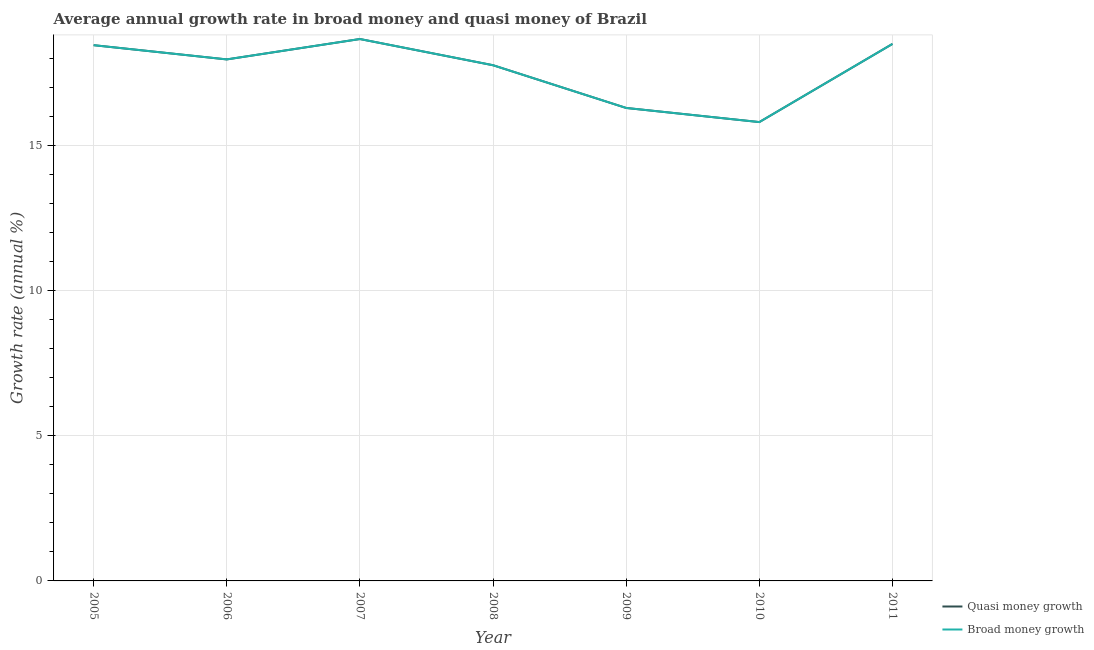Does the line corresponding to annual growth rate in broad money intersect with the line corresponding to annual growth rate in quasi money?
Give a very brief answer. Yes. What is the annual growth rate in broad money in 2005?
Your answer should be very brief. 18.47. Across all years, what is the maximum annual growth rate in broad money?
Offer a terse response. 18.68. Across all years, what is the minimum annual growth rate in broad money?
Ensure brevity in your answer.  15.82. What is the total annual growth rate in broad money in the graph?
Make the answer very short. 123.52. What is the difference between the annual growth rate in quasi money in 2009 and that in 2010?
Offer a very short reply. 0.49. What is the difference between the annual growth rate in quasi money in 2011 and the annual growth rate in broad money in 2009?
Offer a terse response. 2.21. What is the average annual growth rate in quasi money per year?
Your answer should be very brief. 17.65. In the year 2010, what is the difference between the annual growth rate in broad money and annual growth rate in quasi money?
Give a very brief answer. 0. What is the ratio of the annual growth rate in quasi money in 2009 to that in 2010?
Offer a very short reply. 1.03. Is the annual growth rate in quasi money in 2006 less than that in 2009?
Provide a short and direct response. No. What is the difference between the highest and the second highest annual growth rate in broad money?
Provide a short and direct response. 0.17. What is the difference between the highest and the lowest annual growth rate in broad money?
Offer a terse response. 2.86. How many lines are there?
Make the answer very short. 2. How many years are there in the graph?
Provide a short and direct response. 7. Does the graph contain grids?
Make the answer very short. Yes. Where does the legend appear in the graph?
Your answer should be very brief. Bottom right. How many legend labels are there?
Your answer should be compact. 2. What is the title of the graph?
Give a very brief answer. Average annual growth rate in broad money and quasi money of Brazil. Does "Goods and services" appear as one of the legend labels in the graph?
Provide a succinct answer. No. What is the label or title of the X-axis?
Ensure brevity in your answer.  Year. What is the label or title of the Y-axis?
Your response must be concise. Growth rate (annual %). What is the Growth rate (annual %) in Quasi money growth in 2005?
Your answer should be very brief. 18.47. What is the Growth rate (annual %) of Broad money growth in 2005?
Offer a very short reply. 18.47. What is the Growth rate (annual %) of Quasi money growth in 2006?
Offer a terse response. 17.98. What is the Growth rate (annual %) in Broad money growth in 2006?
Your response must be concise. 17.98. What is the Growth rate (annual %) of Quasi money growth in 2007?
Make the answer very short. 18.68. What is the Growth rate (annual %) in Broad money growth in 2007?
Your answer should be very brief. 18.68. What is the Growth rate (annual %) in Quasi money growth in 2008?
Your answer should be compact. 17.78. What is the Growth rate (annual %) of Broad money growth in 2008?
Make the answer very short. 17.78. What is the Growth rate (annual %) in Quasi money growth in 2009?
Make the answer very short. 16.3. What is the Growth rate (annual %) of Broad money growth in 2009?
Keep it short and to the point. 16.3. What is the Growth rate (annual %) in Quasi money growth in 2010?
Your answer should be very brief. 15.82. What is the Growth rate (annual %) of Broad money growth in 2010?
Make the answer very short. 15.82. What is the Growth rate (annual %) of Quasi money growth in 2011?
Offer a terse response. 18.51. What is the Growth rate (annual %) in Broad money growth in 2011?
Provide a succinct answer. 18.51. Across all years, what is the maximum Growth rate (annual %) of Quasi money growth?
Ensure brevity in your answer.  18.68. Across all years, what is the maximum Growth rate (annual %) of Broad money growth?
Ensure brevity in your answer.  18.68. Across all years, what is the minimum Growth rate (annual %) of Quasi money growth?
Your response must be concise. 15.82. Across all years, what is the minimum Growth rate (annual %) in Broad money growth?
Your response must be concise. 15.82. What is the total Growth rate (annual %) in Quasi money growth in the graph?
Ensure brevity in your answer.  123.52. What is the total Growth rate (annual %) of Broad money growth in the graph?
Offer a terse response. 123.52. What is the difference between the Growth rate (annual %) of Quasi money growth in 2005 and that in 2006?
Offer a terse response. 0.49. What is the difference between the Growth rate (annual %) in Broad money growth in 2005 and that in 2006?
Give a very brief answer. 0.49. What is the difference between the Growth rate (annual %) in Quasi money growth in 2005 and that in 2007?
Ensure brevity in your answer.  -0.21. What is the difference between the Growth rate (annual %) in Broad money growth in 2005 and that in 2007?
Make the answer very short. -0.21. What is the difference between the Growth rate (annual %) in Quasi money growth in 2005 and that in 2008?
Provide a short and direct response. 0.69. What is the difference between the Growth rate (annual %) of Broad money growth in 2005 and that in 2008?
Your answer should be compact. 0.69. What is the difference between the Growth rate (annual %) in Quasi money growth in 2005 and that in 2009?
Offer a terse response. 2.16. What is the difference between the Growth rate (annual %) of Broad money growth in 2005 and that in 2009?
Ensure brevity in your answer.  2.16. What is the difference between the Growth rate (annual %) of Quasi money growth in 2005 and that in 2010?
Your answer should be very brief. 2.65. What is the difference between the Growth rate (annual %) of Broad money growth in 2005 and that in 2010?
Provide a succinct answer. 2.65. What is the difference between the Growth rate (annual %) of Quasi money growth in 2005 and that in 2011?
Your answer should be very brief. -0.04. What is the difference between the Growth rate (annual %) of Broad money growth in 2005 and that in 2011?
Your response must be concise. -0.04. What is the difference between the Growth rate (annual %) in Quasi money growth in 2006 and that in 2007?
Offer a very short reply. -0.7. What is the difference between the Growth rate (annual %) of Broad money growth in 2006 and that in 2007?
Ensure brevity in your answer.  -0.7. What is the difference between the Growth rate (annual %) in Quasi money growth in 2006 and that in 2008?
Your response must be concise. 0.2. What is the difference between the Growth rate (annual %) of Broad money growth in 2006 and that in 2008?
Provide a succinct answer. 0.2. What is the difference between the Growth rate (annual %) of Quasi money growth in 2006 and that in 2009?
Make the answer very short. 1.67. What is the difference between the Growth rate (annual %) in Broad money growth in 2006 and that in 2009?
Keep it short and to the point. 1.67. What is the difference between the Growth rate (annual %) of Quasi money growth in 2006 and that in 2010?
Provide a succinct answer. 2.16. What is the difference between the Growth rate (annual %) in Broad money growth in 2006 and that in 2010?
Give a very brief answer. 2.16. What is the difference between the Growth rate (annual %) of Quasi money growth in 2006 and that in 2011?
Provide a short and direct response. -0.53. What is the difference between the Growth rate (annual %) in Broad money growth in 2006 and that in 2011?
Offer a terse response. -0.53. What is the difference between the Growth rate (annual %) in Quasi money growth in 2007 and that in 2008?
Your response must be concise. 0.9. What is the difference between the Growth rate (annual %) of Broad money growth in 2007 and that in 2008?
Keep it short and to the point. 0.9. What is the difference between the Growth rate (annual %) of Quasi money growth in 2007 and that in 2009?
Keep it short and to the point. 2.38. What is the difference between the Growth rate (annual %) in Broad money growth in 2007 and that in 2009?
Provide a short and direct response. 2.38. What is the difference between the Growth rate (annual %) in Quasi money growth in 2007 and that in 2010?
Make the answer very short. 2.86. What is the difference between the Growth rate (annual %) in Broad money growth in 2007 and that in 2010?
Give a very brief answer. 2.86. What is the difference between the Growth rate (annual %) in Quasi money growth in 2007 and that in 2011?
Give a very brief answer. 0.17. What is the difference between the Growth rate (annual %) of Broad money growth in 2007 and that in 2011?
Give a very brief answer. 0.17. What is the difference between the Growth rate (annual %) of Quasi money growth in 2008 and that in 2009?
Keep it short and to the point. 1.47. What is the difference between the Growth rate (annual %) in Broad money growth in 2008 and that in 2009?
Your answer should be compact. 1.47. What is the difference between the Growth rate (annual %) in Quasi money growth in 2008 and that in 2010?
Give a very brief answer. 1.96. What is the difference between the Growth rate (annual %) of Broad money growth in 2008 and that in 2010?
Offer a terse response. 1.96. What is the difference between the Growth rate (annual %) in Quasi money growth in 2008 and that in 2011?
Your response must be concise. -0.73. What is the difference between the Growth rate (annual %) of Broad money growth in 2008 and that in 2011?
Your answer should be compact. -0.73. What is the difference between the Growth rate (annual %) of Quasi money growth in 2009 and that in 2010?
Ensure brevity in your answer.  0.49. What is the difference between the Growth rate (annual %) of Broad money growth in 2009 and that in 2010?
Provide a short and direct response. 0.49. What is the difference between the Growth rate (annual %) in Quasi money growth in 2009 and that in 2011?
Ensure brevity in your answer.  -2.21. What is the difference between the Growth rate (annual %) of Broad money growth in 2009 and that in 2011?
Offer a terse response. -2.21. What is the difference between the Growth rate (annual %) in Quasi money growth in 2010 and that in 2011?
Offer a terse response. -2.69. What is the difference between the Growth rate (annual %) in Broad money growth in 2010 and that in 2011?
Provide a succinct answer. -2.69. What is the difference between the Growth rate (annual %) of Quasi money growth in 2005 and the Growth rate (annual %) of Broad money growth in 2006?
Ensure brevity in your answer.  0.49. What is the difference between the Growth rate (annual %) in Quasi money growth in 2005 and the Growth rate (annual %) in Broad money growth in 2007?
Keep it short and to the point. -0.21. What is the difference between the Growth rate (annual %) of Quasi money growth in 2005 and the Growth rate (annual %) of Broad money growth in 2008?
Ensure brevity in your answer.  0.69. What is the difference between the Growth rate (annual %) in Quasi money growth in 2005 and the Growth rate (annual %) in Broad money growth in 2009?
Your response must be concise. 2.16. What is the difference between the Growth rate (annual %) in Quasi money growth in 2005 and the Growth rate (annual %) in Broad money growth in 2010?
Ensure brevity in your answer.  2.65. What is the difference between the Growth rate (annual %) of Quasi money growth in 2005 and the Growth rate (annual %) of Broad money growth in 2011?
Offer a terse response. -0.04. What is the difference between the Growth rate (annual %) in Quasi money growth in 2006 and the Growth rate (annual %) in Broad money growth in 2007?
Make the answer very short. -0.7. What is the difference between the Growth rate (annual %) of Quasi money growth in 2006 and the Growth rate (annual %) of Broad money growth in 2008?
Provide a short and direct response. 0.2. What is the difference between the Growth rate (annual %) of Quasi money growth in 2006 and the Growth rate (annual %) of Broad money growth in 2009?
Provide a succinct answer. 1.67. What is the difference between the Growth rate (annual %) of Quasi money growth in 2006 and the Growth rate (annual %) of Broad money growth in 2010?
Keep it short and to the point. 2.16. What is the difference between the Growth rate (annual %) in Quasi money growth in 2006 and the Growth rate (annual %) in Broad money growth in 2011?
Offer a very short reply. -0.53. What is the difference between the Growth rate (annual %) in Quasi money growth in 2007 and the Growth rate (annual %) in Broad money growth in 2008?
Provide a short and direct response. 0.9. What is the difference between the Growth rate (annual %) of Quasi money growth in 2007 and the Growth rate (annual %) of Broad money growth in 2009?
Make the answer very short. 2.38. What is the difference between the Growth rate (annual %) of Quasi money growth in 2007 and the Growth rate (annual %) of Broad money growth in 2010?
Your answer should be compact. 2.86. What is the difference between the Growth rate (annual %) of Quasi money growth in 2007 and the Growth rate (annual %) of Broad money growth in 2011?
Make the answer very short. 0.17. What is the difference between the Growth rate (annual %) of Quasi money growth in 2008 and the Growth rate (annual %) of Broad money growth in 2009?
Your answer should be very brief. 1.47. What is the difference between the Growth rate (annual %) in Quasi money growth in 2008 and the Growth rate (annual %) in Broad money growth in 2010?
Offer a very short reply. 1.96. What is the difference between the Growth rate (annual %) of Quasi money growth in 2008 and the Growth rate (annual %) of Broad money growth in 2011?
Make the answer very short. -0.73. What is the difference between the Growth rate (annual %) of Quasi money growth in 2009 and the Growth rate (annual %) of Broad money growth in 2010?
Your answer should be very brief. 0.49. What is the difference between the Growth rate (annual %) of Quasi money growth in 2009 and the Growth rate (annual %) of Broad money growth in 2011?
Make the answer very short. -2.21. What is the difference between the Growth rate (annual %) of Quasi money growth in 2010 and the Growth rate (annual %) of Broad money growth in 2011?
Provide a succinct answer. -2.69. What is the average Growth rate (annual %) of Quasi money growth per year?
Provide a short and direct response. 17.65. What is the average Growth rate (annual %) in Broad money growth per year?
Keep it short and to the point. 17.65. In the year 2005, what is the difference between the Growth rate (annual %) of Quasi money growth and Growth rate (annual %) of Broad money growth?
Provide a short and direct response. 0. In the year 2009, what is the difference between the Growth rate (annual %) of Quasi money growth and Growth rate (annual %) of Broad money growth?
Your answer should be compact. 0. In the year 2010, what is the difference between the Growth rate (annual %) in Quasi money growth and Growth rate (annual %) in Broad money growth?
Offer a very short reply. 0. What is the ratio of the Growth rate (annual %) in Quasi money growth in 2005 to that in 2006?
Ensure brevity in your answer.  1.03. What is the ratio of the Growth rate (annual %) in Broad money growth in 2005 to that in 2006?
Provide a succinct answer. 1.03. What is the ratio of the Growth rate (annual %) of Quasi money growth in 2005 to that in 2007?
Make the answer very short. 0.99. What is the ratio of the Growth rate (annual %) in Broad money growth in 2005 to that in 2007?
Your answer should be very brief. 0.99. What is the ratio of the Growth rate (annual %) of Quasi money growth in 2005 to that in 2008?
Your answer should be compact. 1.04. What is the ratio of the Growth rate (annual %) in Broad money growth in 2005 to that in 2008?
Ensure brevity in your answer.  1.04. What is the ratio of the Growth rate (annual %) in Quasi money growth in 2005 to that in 2009?
Give a very brief answer. 1.13. What is the ratio of the Growth rate (annual %) in Broad money growth in 2005 to that in 2009?
Your response must be concise. 1.13. What is the ratio of the Growth rate (annual %) of Quasi money growth in 2005 to that in 2010?
Your answer should be compact. 1.17. What is the ratio of the Growth rate (annual %) of Broad money growth in 2005 to that in 2010?
Make the answer very short. 1.17. What is the ratio of the Growth rate (annual %) in Quasi money growth in 2006 to that in 2007?
Your response must be concise. 0.96. What is the ratio of the Growth rate (annual %) of Broad money growth in 2006 to that in 2007?
Provide a succinct answer. 0.96. What is the ratio of the Growth rate (annual %) of Quasi money growth in 2006 to that in 2008?
Make the answer very short. 1.01. What is the ratio of the Growth rate (annual %) of Broad money growth in 2006 to that in 2008?
Your answer should be compact. 1.01. What is the ratio of the Growth rate (annual %) of Quasi money growth in 2006 to that in 2009?
Provide a short and direct response. 1.1. What is the ratio of the Growth rate (annual %) of Broad money growth in 2006 to that in 2009?
Your answer should be very brief. 1.1. What is the ratio of the Growth rate (annual %) in Quasi money growth in 2006 to that in 2010?
Ensure brevity in your answer.  1.14. What is the ratio of the Growth rate (annual %) of Broad money growth in 2006 to that in 2010?
Provide a succinct answer. 1.14. What is the ratio of the Growth rate (annual %) of Quasi money growth in 2006 to that in 2011?
Ensure brevity in your answer.  0.97. What is the ratio of the Growth rate (annual %) of Broad money growth in 2006 to that in 2011?
Make the answer very short. 0.97. What is the ratio of the Growth rate (annual %) in Quasi money growth in 2007 to that in 2008?
Offer a terse response. 1.05. What is the ratio of the Growth rate (annual %) of Broad money growth in 2007 to that in 2008?
Your response must be concise. 1.05. What is the ratio of the Growth rate (annual %) of Quasi money growth in 2007 to that in 2009?
Your response must be concise. 1.15. What is the ratio of the Growth rate (annual %) in Broad money growth in 2007 to that in 2009?
Provide a short and direct response. 1.15. What is the ratio of the Growth rate (annual %) of Quasi money growth in 2007 to that in 2010?
Offer a very short reply. 1.18. What is the ratio of the Growth rate (annual %) of Broad money growth in 2007 to that in 2010?
Your response must be concise. 1.18. What is the ratio of the Growth rate (annual %) of Quasi money growth in 2007 to that in 2011?
Your answer should be very brief. 1.01. What is the ratio of the Growth rate (annual %) of Broad money growth in 2007 to that in 2011?
Provide a short and direct response. 1.01. What is the ratio of the Growth rate (annual %) of Quasi money growth in 2008 to that in 2009?
Provide a short and direct response. 1.09. What is the ratio of the Growth rate (annual %) of Broad money growth in 2008 to that in 2009?
Provide a short and direct response. 1.09. What is the ratio of the Growth rate (annual %) in Quasi money growth in 2008 to that in 2010?
Your answer should be very brief. 1.12. What is the ratio of the Growth rate (annual %) in Broad money growth in 2008 to that in 2010?
Your answer should be compact. 1.12. What is the ratio of the Growth rate (annual %) of Quasi money growth in 2008 to that in 2011?
Ensure brevity in your answer.  0.96. What is the ratio of the Growth rate (annual %) of Broad money growth in 2008 to that in 2011?
Your response must be concise. 0.96. What is the ratio of the Growth rate (annual %) in Quasi money growth in 2009 to that in 2010?
Offer a very short reply. 1.03. What is the ratio of the Growth rate (annual %) in Broad money growth in 2009 to that in 2010?
Your answer should be compact. 1.03. What is the ratio of the Growth rate (annual %) of Quasi money growth in 2009 to that in 2011?
Provide a succinct answer. 0.88. What is the ratio of the Growth rate (annual %) of Broad money growth in 2009 to that in 2011?
Provide a succinct answer. 0.88. What is the ratio of the Growth rate (annual %) of Quasi money growth in 2010 to that in 2011?
Your answer should be very brief. 0.85. What is the ratio of the Growth rate (annual %) in Broad money growth in 2010 to that in 2011?
Provide a succinct answer. 0.85. What is the difference between the highest and the second highest Growth rate (annual %) in Quasi money growth?
Your answer should be compact. 0.17. What is the difference between the highest and the second highest Growth rate (annual %) of Broad money growth?
Offer a terse response. 0.17. What is the difference between the highest and the lowest Growth rate (annual %) of Quasi money growth?
Give a very brief answer. 2.86. What is the difference between the highest and the lowest Growth rate (annual %) in Broad money growth?
Keep it short and to the point. 2.86. 